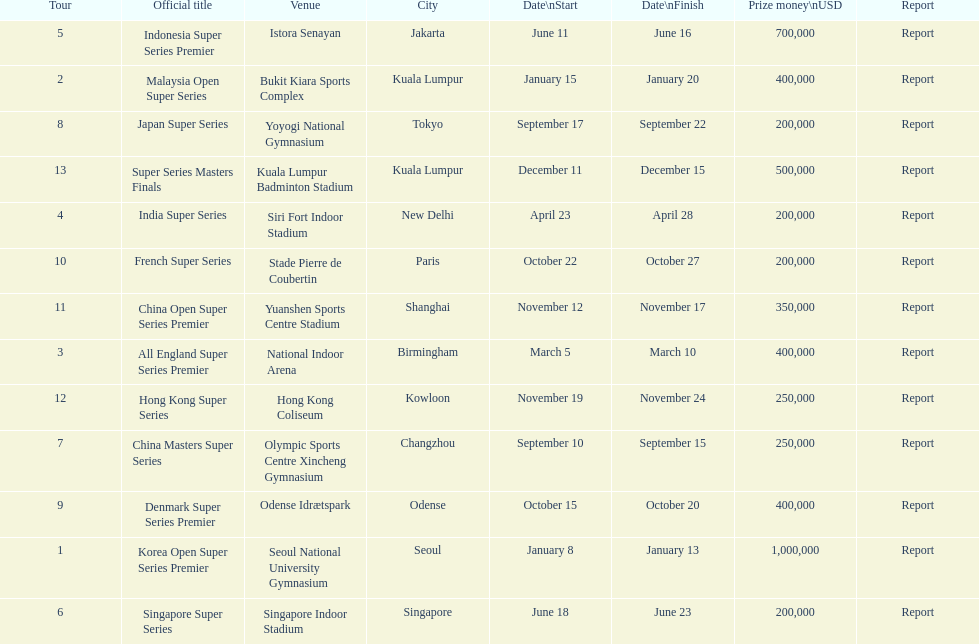How many days does the japan super series last? 5. 